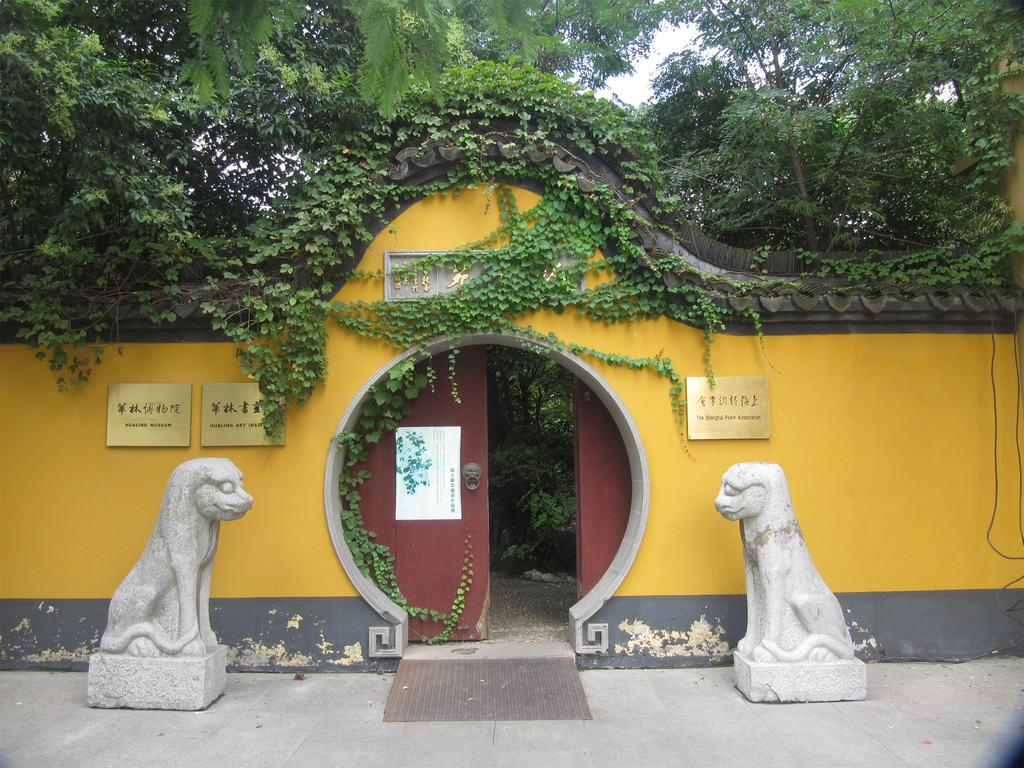What type of artwork can be seen in the image? There are sculptures in the image. What is the primary architectural feature visible in the image? There is an entrance door in the image. What type of signage is present in the image? There are boards with text in the image. What type of vegetation is present in the image? Creepers and trees are present in the image. What is visible in the background of the image? The sky is visible in the image. Can you see any guns in the image? No, there are no guns present in the image. How many toes are visible on the sculptures in the image? There is no mention of toes or sculptures with feet in the provided facts, so it cannot be determined from the image. 